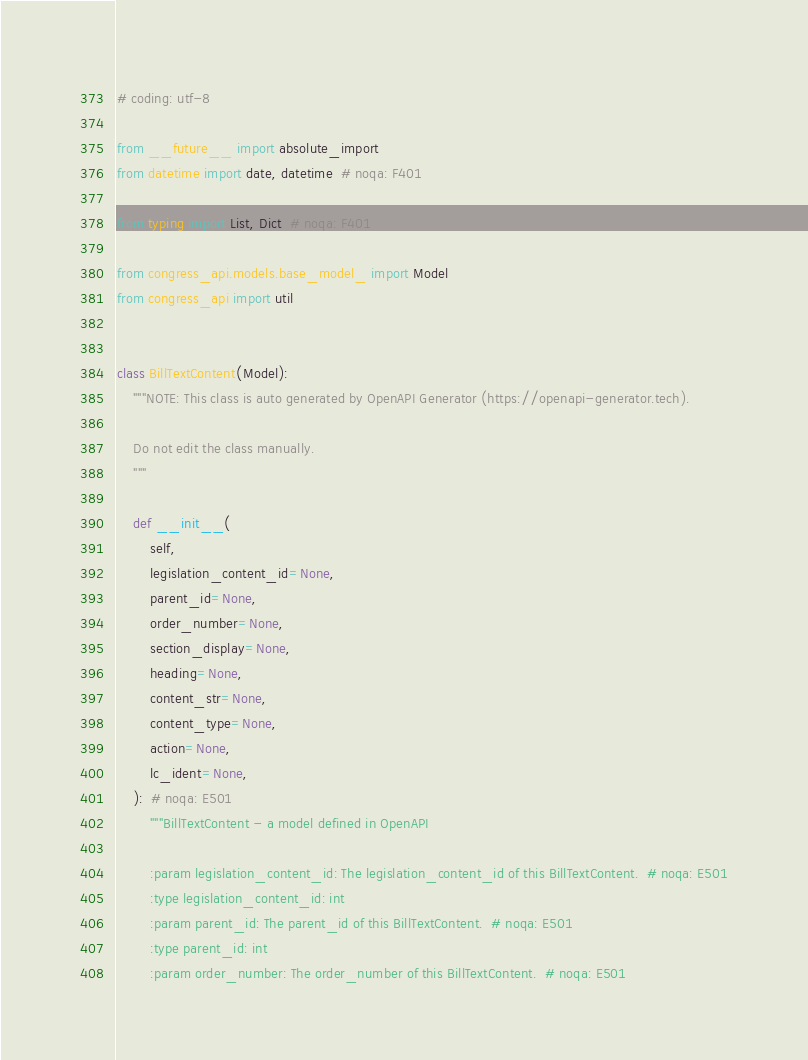<code> <loc_0><loc_0><loc_500><loc_500><_Python_># coding: utf-8

from __future__ import absolute_import
from datetime import date, datetime  # noqa: F401

from typing import List, Dict  # noqa: F401

from congress_api.models.base_model_ import Model
from congress_api import util


class BillTextContent(Model):
    """NOTE: This class is auto generated by OpenAPI Generator (https://openapi-generator.tech).

    Do not edit the class manually.
    """

    def __init__(
        self,
        legislation_content_id=None,
        parent_id=None,
        order_number=None,
        section_display=None,
        heading=None,
        content_str=None,
        content_type=None,
        action=None,
        lc_ident=None,
    ):  # noqa: E501
        """BillTextContent - a model defined in OpenAPI

        :param legislation_content_id: The legislation_content_id of this BillTextContent.  # noqa: E501
        :type legislation_content_id: int
        :param parent_id: The parent_id of this BillTextContent.  # noqa: E501
        :type parent_id: int
        :param order_number: The order_number of this BillTextContent.  # noqa: E501</code> 